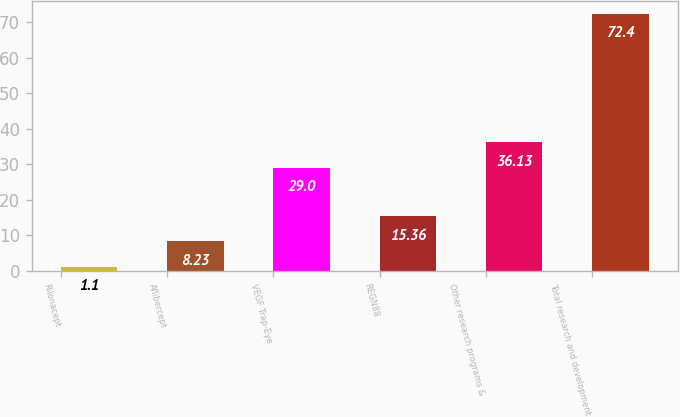<chart> <loc_0><loc_0><loc_500><loc_500><bar_chart><fcel>Rilonacept<fcel>Aflibercept<fcel>VEGF Trap-Eye<fcel>REGN88<fcel>Other research programs &<fcel>Total research and development<nl><fcel>1.1<fcel>8.23<fcel>29<fcel>15.36<fcel>36.13<fcel>72.4<nl></chart> 